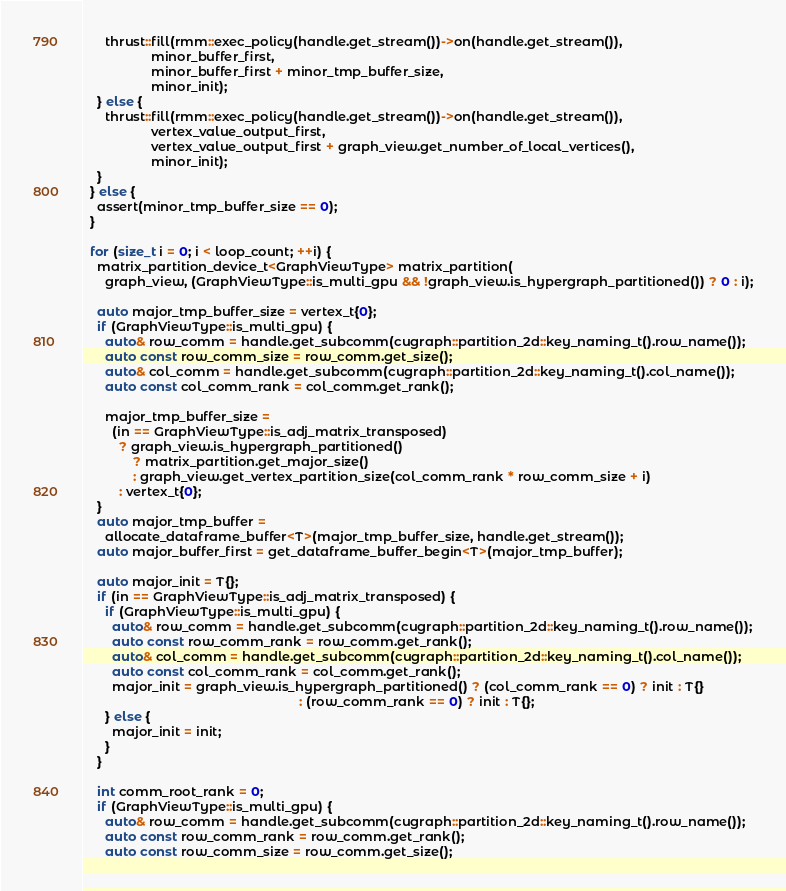<code> <loc_0><loc_0><loc_500><loc_500><_Cuda_>      thrust::fill(rmm::exec_policy(handle.get_stream())->on(handle.get_stream()),
                   minor_buffer_first,
                   minor_buffer_first + minor_tmp_buffer_size,
                   minor_init);
    } else {
      thrust::fill(rmm::exec_policy(handle.get_stream())->on(handle.get_stream()),
                   vertex_value_output_first,
                   vertex_value_output_first + graph_view.get_number_of_local_vertices(),
                   minor_init);
    }
  } else {
    assert(minor_tmp_buffer_size == 0);
  }

  for (size_t i = 0; i < loop_count; ++i) {
    matrix_partition_device_t<GraphViewType> matrix_partition(
      graph_view, (GraphViewType::is_multi_gpu && !graph_view.is_hypergraph_partitioned()) ? 0 : i);

    auto major_tmp_buffer_size = vertex_t{0};
    if (GraphViewType::is_multi_gpu) {
      auto& row_comm = handle.get_subcomm(cugraph::partition_2d::key_naming_t().row_name());
      auto const row_comm_size = row_comm.get_size();
      auto& col_comm = handle.get_subcomm(cugraph::partition_2d::key_naming_t().col_name());
      auto const col_comm_rank = col_comm.get_rank();

      major_tmp_buffer_size =
        (in == GraphViewType::is_adj_matrix_transposed)
          ? graph_view.is_hypergraph_partitioned()
              ? matrix_partition.get_major_size()
              : graph_view.get_vertex_partition_size(col_comm_rank * row_comm_size + i)
          : vertex_t{0};
    }
    auto major_tmp_buffer =
      allocate_dataframe_buffer<T>(major_tmp_buffer_size, handle.get_stream());
    auto major_buffer_first = get_dataframe_buffer_begin<T>(major_tmp_buffer);

    auto major_init = T{};
    if (in == GraphViewType::is_adj_matrix_transposed) {
      if (GraphViewType::is_multi_gpu) {
        auto& row_comm = handle.get_subcomm(cugraph::partition_2d::key_naming_t().row_name());
        auto const row_comm_rank = row_comm.get_rank();
        auto& col_comm = handle.get_subcomm(cugraph::partition_2d::key_naming_t().col_name());
        auto const col_comm_rank = col_comm.get_rank();
        major_init = graph_view.is_hypergraph_partitioned() ? (col_comm_rank == 0) ? init : T{}
                                                            : (row_comm_rank == 0) ? init : T{};
      } else {
        major_init = init;
      }
    }

    int comm_root_rank = 0;
    if (GraphViewType::is_multi_gpu) {
      auto& row_comm = handle.get_subcomm(cugraph::partition_2d::key_naming_t().row_name());
      auto const row_comm_rank = row_comm.get_rank();
      auto const row_comm_size = row_comm.get_size();</code> 